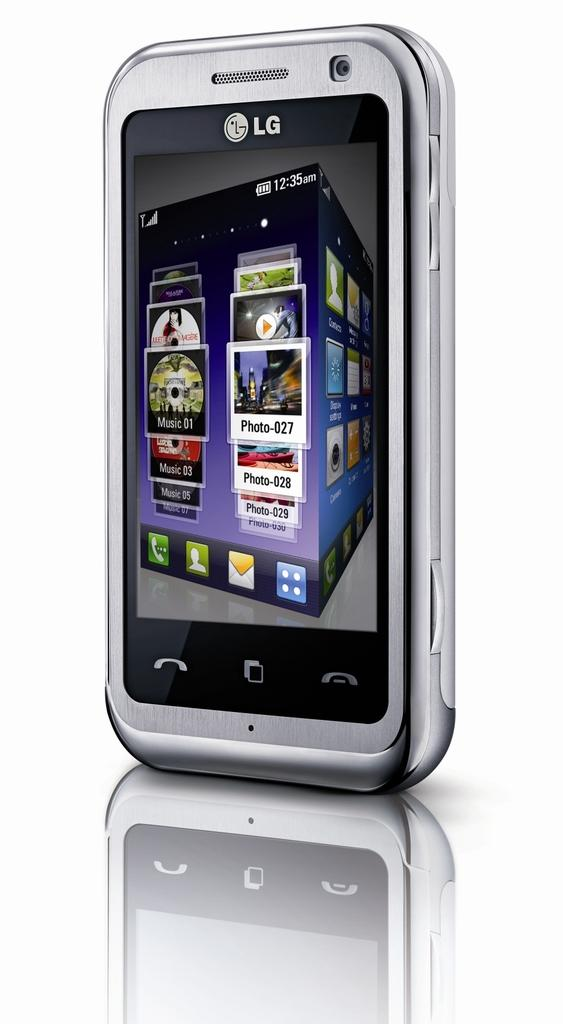<image>
Offer a succinct explanation of the picture presented. LG is the brand shown on the top of this smart phone. 